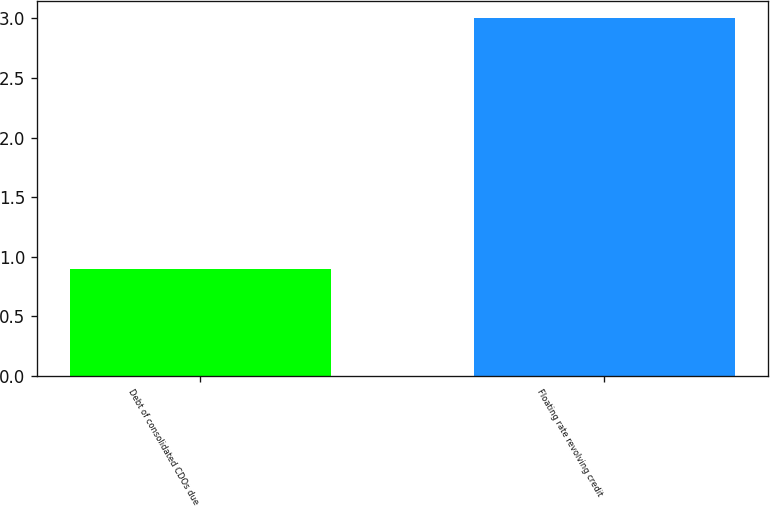Convert chart. <chart><loc_0><loc_0><loc_500><loc_500><bar_chart><fcel>Debt of consolidated CDOs due<fcel>Floating rate revolving credit<nl><fcel>0.9<fcel>3<nl></chart> 